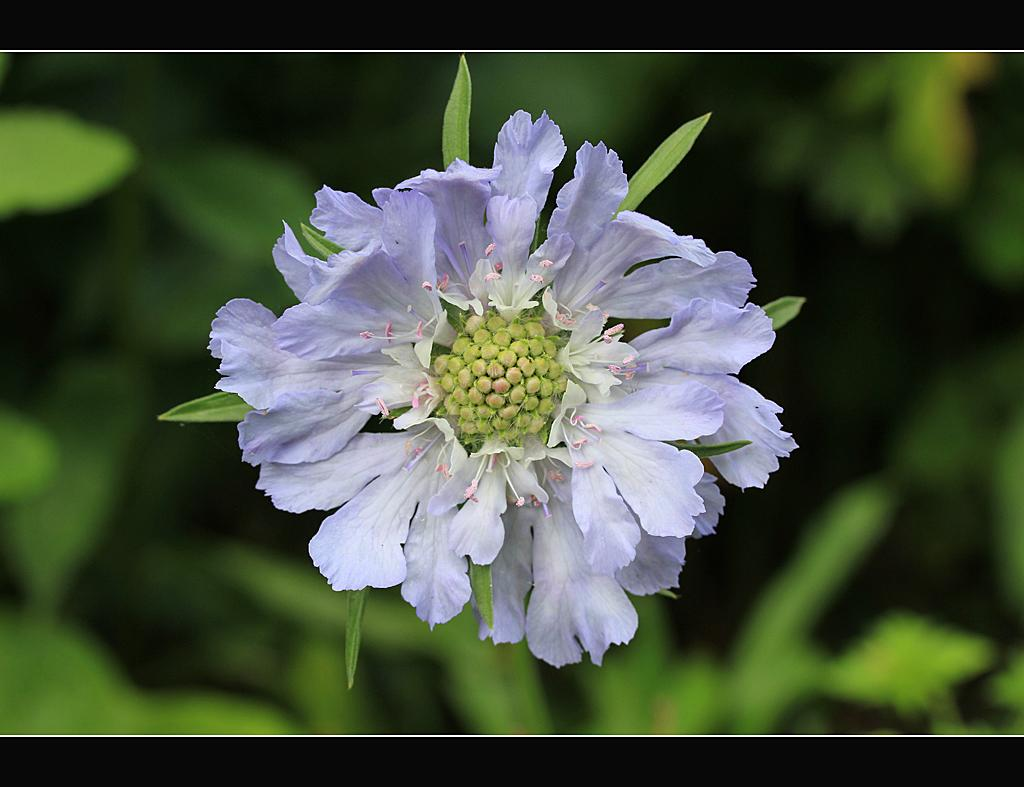What is the main subject of the image? There is a flower in the image. Can you describe the background of the image? The background of the image is blurred. What type of animal can be seen sitting on the seat in the image? There is no animal or seat present in the image; it features a flower with a blurred background. 